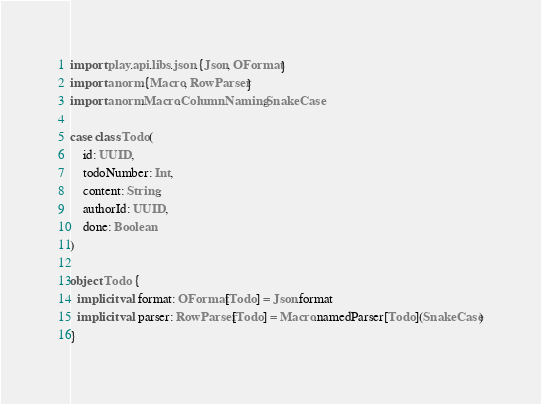<code> <loc_0><loc_0><loc_500><loc_500><_Scala_>import play.api.libs.json.{Json, OFormat}
import anorm.{Macro, RowParser}
import anorm.Macro.ColumnNaming.SnakeCase

case class Todo(
    id: UUID,
    todoNumber: Int,
    content: String,
    authorId: UUID,
    done: Boolean
)

object Todo {
  implicit val format: OFormat[Todo] = Json.format
  implicit val parser: RowParser[Todo] = Macro.namedParser[Todo](SnakeCase)
}
</code> 